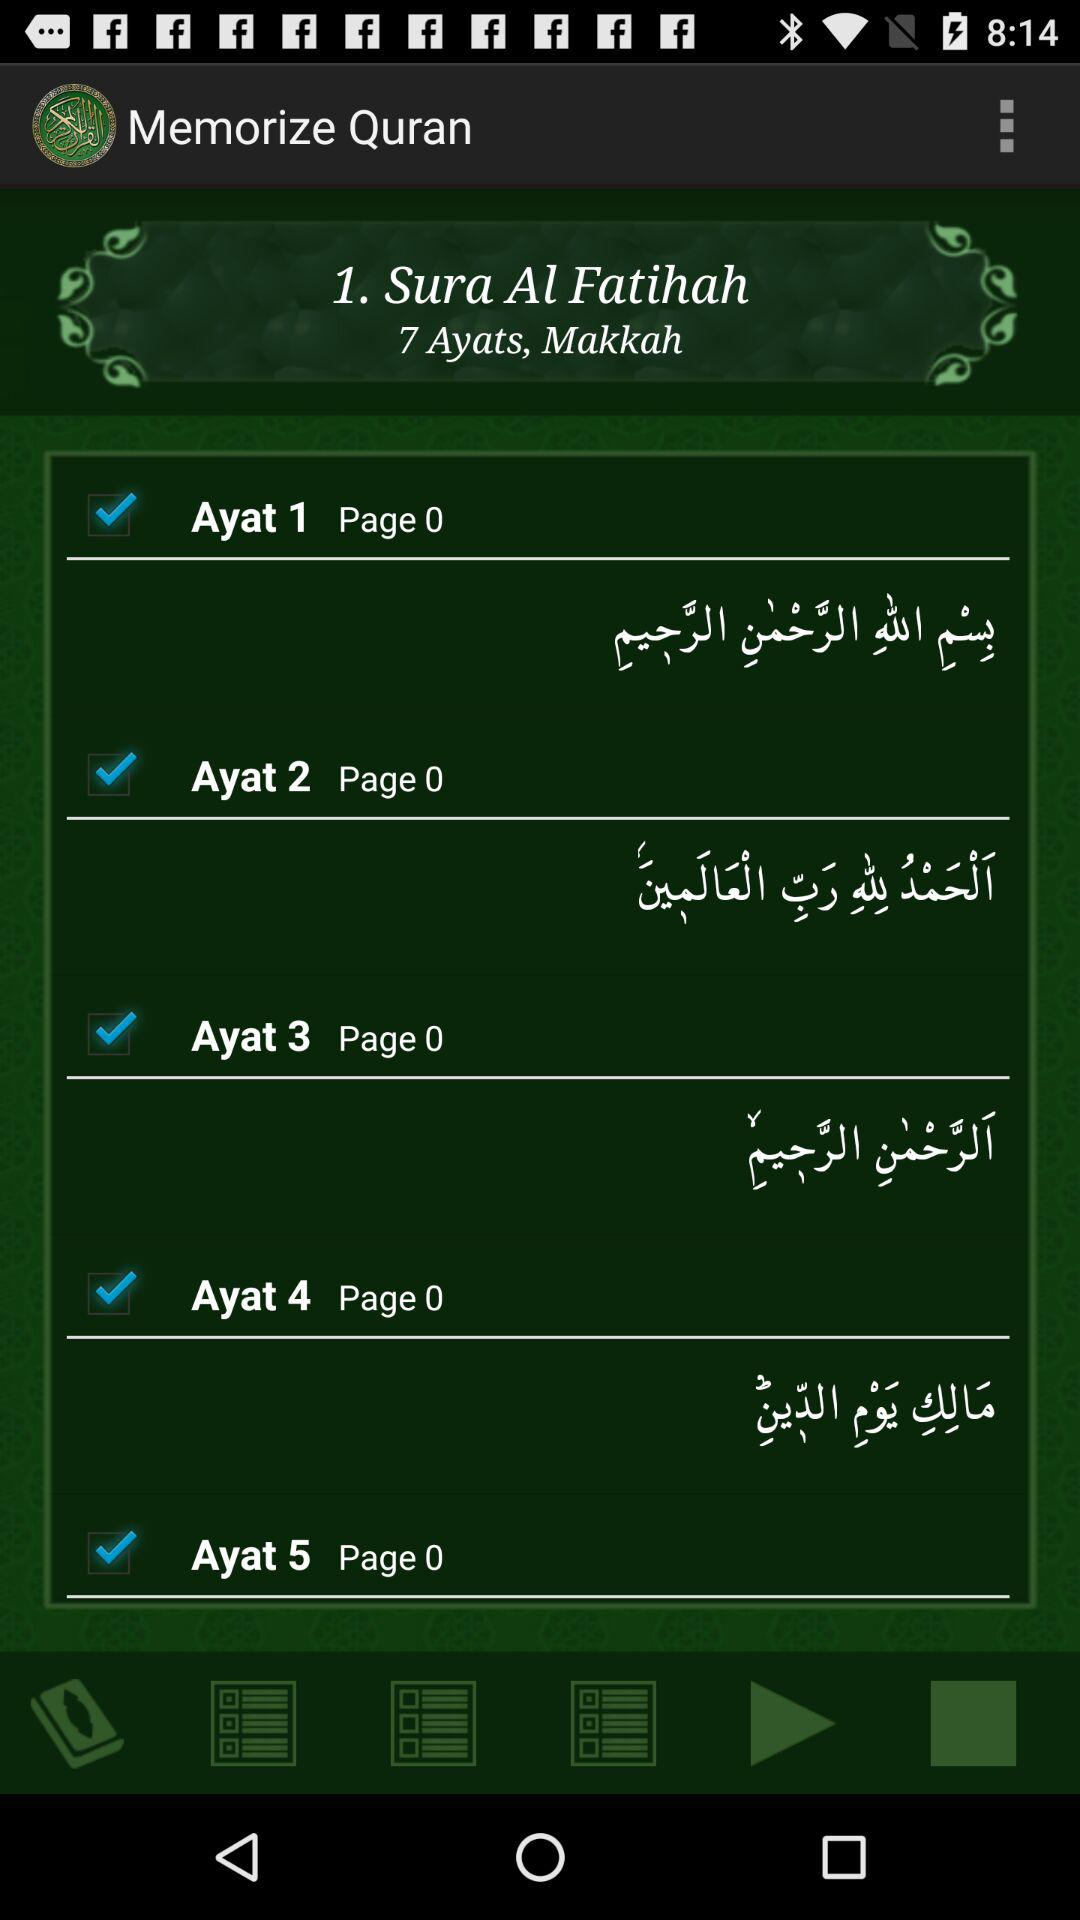How many Ayats are in Sura Al Fatihah?
Answer the question using a single word or phrase. 7 